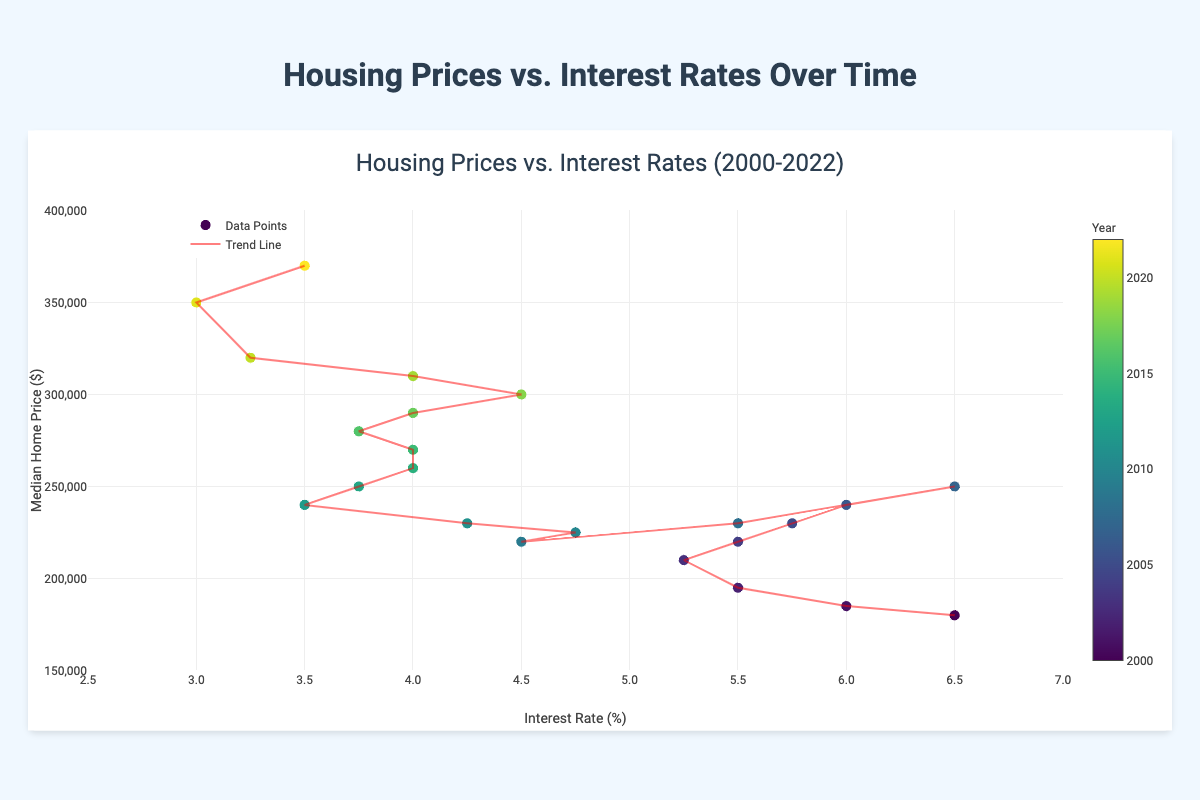What is the title of the chart? The title of the chart is displayed at the top of the figure, which provides an overview of what the chart is about. The title reads "Housing Prices vs. Interest Rates (2000-2022)".
Answer: Housing Prices vs. Interest Rates (2000-2022) What is the range of the x-axis? The x-axis represents the Interest Rate (%) and its range is indicated at the bottom of the chart. The chart shows that the x-axis ranges from 2.5% to 7%.
Answer: 2.5 to 7% What is the range of the y-axis? The y-axis represents the Median Home Price ($) and its range is indicated along the left side of the chart. The chart shows that the y-axis ranges from $150,000 to $400,000.
Answer: 150,000 to 400,000 How many data points are plotted on the chart? Each year from 2000 to 2022 has a corresponding data point plotted on the chart. By counting each marker that represents a year, we can see there are 23 data points.
Answer: 23 What year corresponds to the highest median home price? By examining the markers' hover information or the color scale, the year with the highest median home price is the one located at the highest point on the y-axis. This year corresponds to 2022 with a median home price of $370,000.
Answer: 2022 How is the data color-coded in the scatter plot? The data is color-coded using a colorscale that ranges from lighter to darker shades, showing a progression over time. A colorbar shows the mapping from color to the respective year, allowing easy identification of data points based on their color.
Answer: Based on the year Which year had the lowest interest rate, and what was the corresponding median home price? By checking the x-axis and seeing the lowest plotted point's hover information, the year with the lowest interest rate was 2021 at 3.0%. The corresponding median home price was $350,000.
Answer: 2021, $350,000 What is the general trend shown by the trend line? The trend line represents the overall relationship between interest rates and median home prices over time. By observing the direction and slope of the trend line, it indicates that as interest rates decrease, median home prices tend to increase, showing an inverse relationship.
Answer: As interest rates decrease, median home prices increase Identify the years where the interest rate was 4.0% and determine their corresponding median home prices. Checking the plot where interest rates equal 4.0%, we find several data points. The corresponding years are 2014, 2015, 2017, and 2019, with median home prices of $260,000, $270,000, $290,000, and $310,000 respectively.
Answer: 2014 ($260,000), 2015 ($270,000), 2017 ($290,000), 2019 ($310,000) Which year saw the highest drop in interest rate from the previous year? By how much did it drop? Looking at the changes in interest rates year over year, the year with the biggest drop can be visually checked. From 2008 to 2009, the interest rate dropped from 5.5% to 4.5%, which is a decrease of 1.0%.
Answer: 2009, 1.0% 